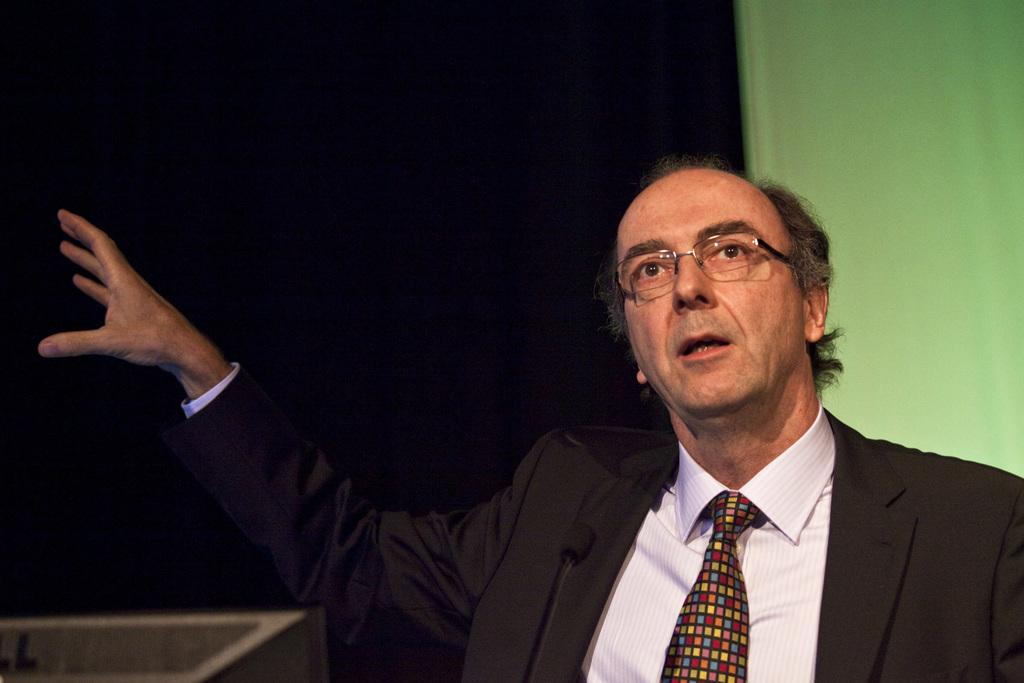Who or what is the main subject of the image? There is a person in the image. What is the person wearing around their neck? The person is wearing a tie. What type of eyewear is the person wearing? The person is wearing spectacles. How would you describe the overall lighting or color of the background in the image? The background of the image is dark. How many bears can be seen in the image? There are no bears present in the image. What type of division is being performed by the person in the image? The image does not show any division or mathematical operation being performed. 